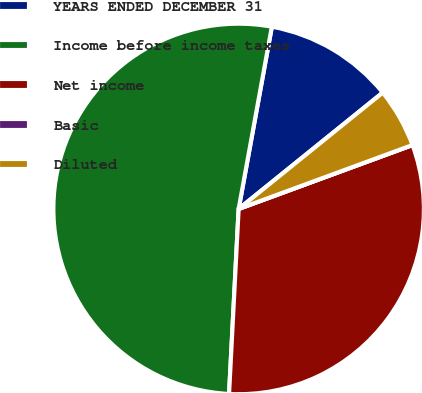Convert chart to OTSL. <chart><loc_0><loc_0><loc_500><loc_500><pie_chart><fcel>YEARS ENDED DECEMBER 31<fcel>Income before income taxes<fcel>Net income<fcel>Basic<fcel>Diluted<nl><fcel>11.32%<fcel>52.04%<fcel>31.43%<fcel>0.0%<fcel>5.2%<nl></chart> 